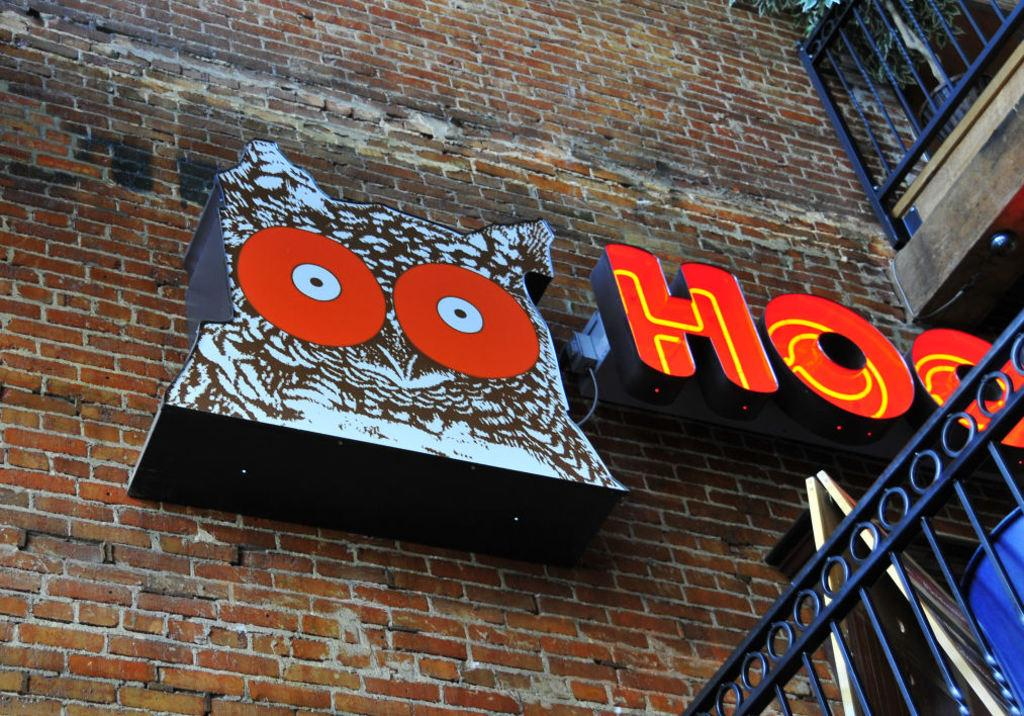<image>
Summarize the visual content of the image. brick wall with owl and hooters sign and there is a blue railing 